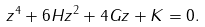Convert formula to latex. <formula><loc_0><loc_0><loc_500><loc_500>z ^ { 4 } + 6 H z ^ { 2 } + 4 G z + K = 0 .</formula> 